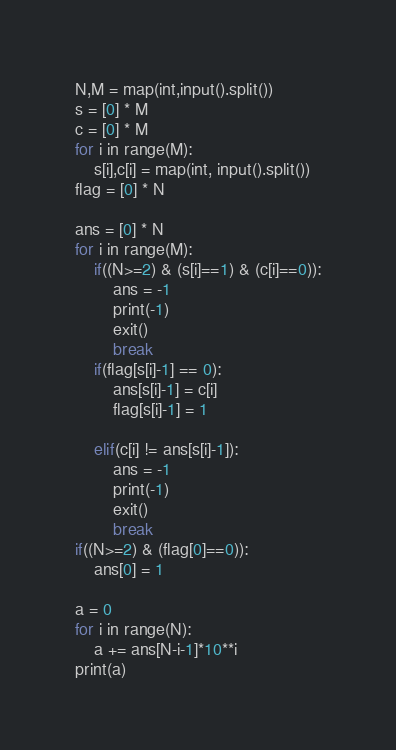Convert code to text. <code><loc_0><loc_0><loc_500><loc_500><_Python_>N,M = map(int,input().split())
s = [0] * M
c = [0] * M
for i in range(M):
    s[i],c[i] = map(int, input().split())
flag = [0] * N

ans = [0] * N
for i in range(M):
    if((N>=2) & (s[i]==1) & (c[i]==0)):
        ans = -1
        print(-1)
        exit()
        break
    if(flag[s[i]-1] == 0):
        ans[s[i]-1] = c[i]
        flag[s[i]-1] = 1
    
    elif(c[i] != ans[s[i]-1]):
        ans = -1
        print(-1)
        exit()
        break
if((N>=2) & (flag[0]==0)):
    ans[0] = 1

a = 0
for i in range(N):
    a += ans[N-i-1]*10**i
print(a)</code> 